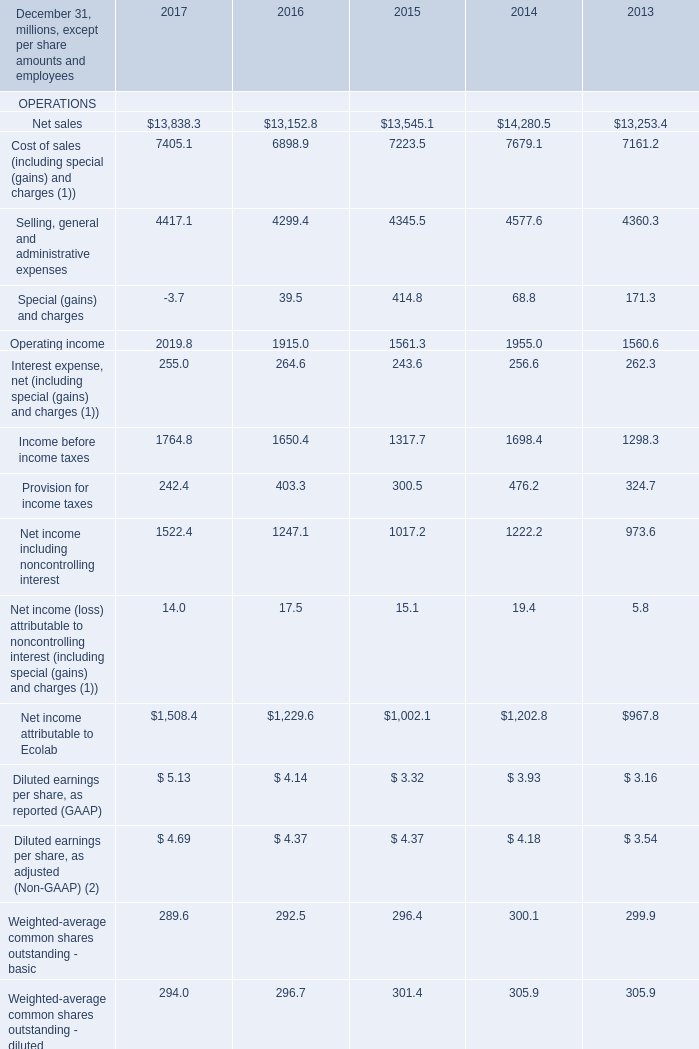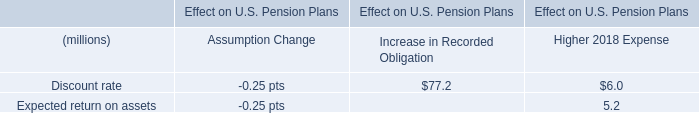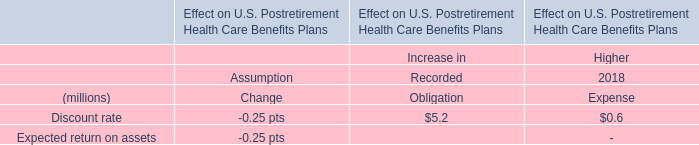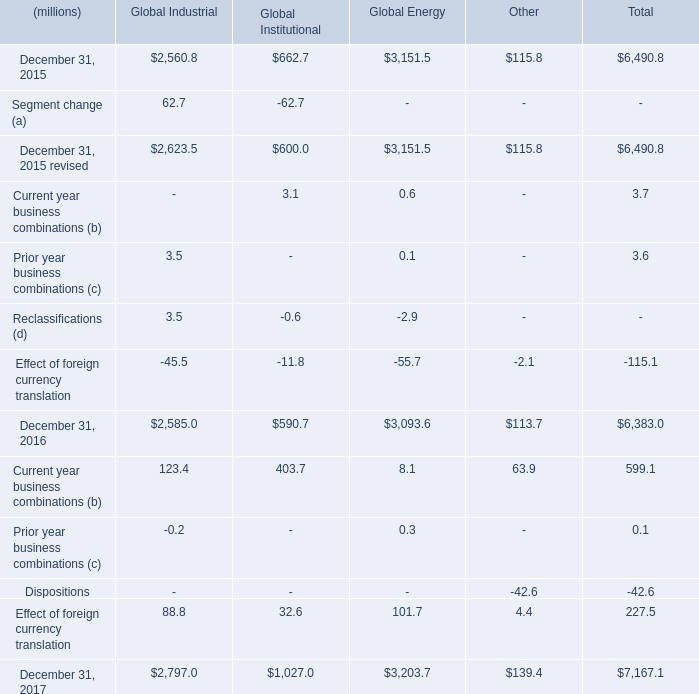What is the growing rate of net sales in the years with the least Cost of sales (including special (gains) and charges (1))? 
Computations: ((13152.8 - 13545.1) / 13545.1)
Answer: -0.02896. 